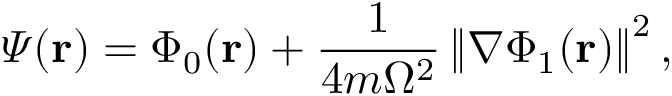<formula> <loc_0><loc_0><loc_500><loc_500>\varPsi ( r ) = \Phi _ { 0 } ( r ) + \frac { 1 } { 4 m \Omega ^ { 2 } } \left \| \nabla \Phi _ { 1 } ( r ) \right \| ^ { 2 } ,</formula> 